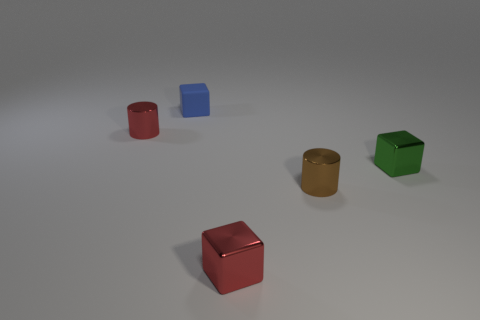The other metallic thing that is the same shape as the green metal thing is what color?
Offer a very short reply. Red. Is there any other thing that has the same shape as the matte thing?
Your answer should be very brief. Yes. There is another small cylinder that is made of the same material as the red cylinder; what is its color?
Ensure brevity in your answer.  Brown. There is a red object in front of the small shiny object that is left of the tiny red block; is there a small metallic cylinder that is left of it?
Keep it short and to the point. Yes. Are there fewer green cubes in front of the green shiny thing than tiny matte blocks that are in front of the blue rubber object?
Make the answer very short. No. How many blocks are the same material as the small red cylinder?
Keep it short and to the point. 2. There is a brown object; does it have the same size as the blue matte block left of the tiny green cube?
Give a very brief answer. Yes. There is a brown metal cylinder that is behind the block that is in front of the shiny cylinder that is in front of the tiny red cylinder; what is its size?
Keep it short and to the point. Small. Are there more red metallic cubes to the right of the red metallic cube than small red objects that are in front of the small green object?
Offer a very short reply. No. There is a small metal cylinder in front of the small green thing; how many tiny metal cubes are in front of it?
Your answer should be compact. 1. 